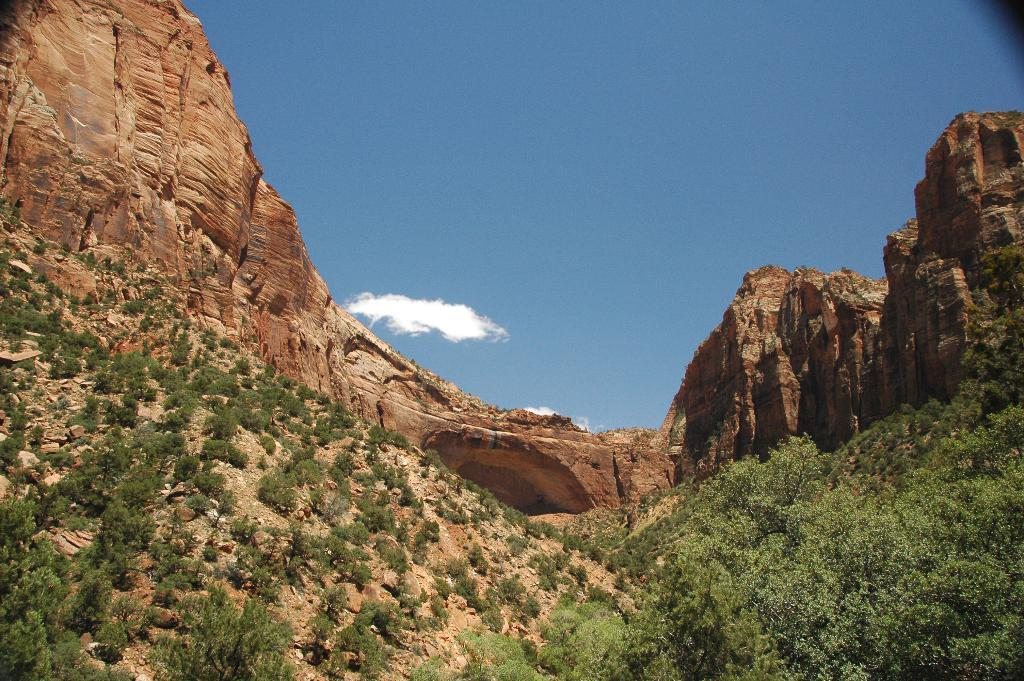What type of vegetation can be seen in the image? There are trees in the image. What type of geographical feature is present in the image? There are hills in the image. What part of the natural environment is visible in the image? The sky is visible in the image. What type of throat problem is the person in the image experiencing? There is no person present in the image, and therefore no throat problem can be observed. Can you tell me how many cars are visible in the image? There are no cars present in the image. 